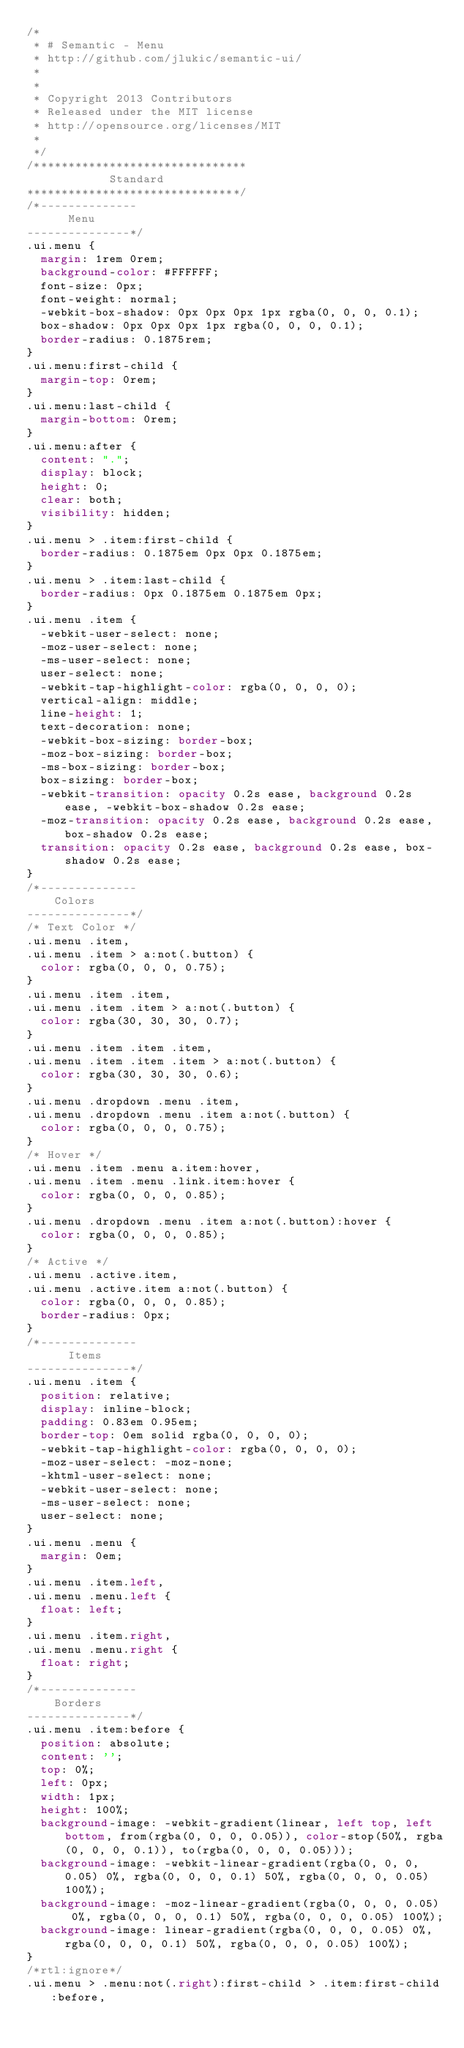<code> <loc_0><loc_0><loc_500><loc_500><_CSS_>/*
 * # Semantic - Menu
 * http://github.com/jlukic/semantic-ui/
 *
 *
 * Copyright 2013 Contributors
 * Released under the MIT license
 * http://opensource.org/licenses/MIT
 *
 */
/*******************************
            Standard
*******************************/
/*--------------
      Menu
---------------*/
.ui.menu {
  margin: 1rem 0rem;
  background-color: #FFFFFF;
  font-size: 0px;
  font-weight: normal;
  -webkit-box-shadow: 0px 0px 0px 1px rgba(0, 0, 0, 0.1);
  box-shadow: 0px 0px 0px 1px rgba(0, 0, 0, 0.1);
  border-radius: 0.1875rem;
}
.ui.menu:first-child {
  margin-top: 0rem;
}
.ui.menu:last-child {
  margin-bottom: 0rem;
}
.ui.menu:after {
  content: ".";
  display: block;
  height: 0;
  clear: both;
  visibility: hidden;
}
.ui.menu > .item:first-child {
  border-radius: 0.1875em 0px 0px 0.1875em;
}
.ui.menu > .item:last-child {
  border-radius: 0px 0.1875em 0.1875em 0px;
}
.ui.menu .item {
  -webkit-user-select: none;
  -moz-user-select: none;
  -ms-user-select: none;
  user-select: none;
  -webkit-tap-highlight-color: rgba(0, 0, 0, 0);
  vertical-align: middle;
  line-height: 1;
  text-decoration: none;
  -webkit-box-sizing: border-box;
  -moz-box-sizing: border-box;
  -ms-box-sizing: border-box;
  box-sizing: border-box;
  -webkit-transition: opacity 0.2s ease, background 0.2s ease, -webkit-box-shadow 0.2s ease;
  -moz-transition: opacity 0.2s ease, background 0.2s ease, box-shadow 0.2s ease;
  transition: opacity 0.2s ease, background 0.2s ease, box-shadow 0.2s ease;
}
/*--------------
    Colors
---------------*/
/* Text Color */
.ui.menu .item,
.ui.menu .item > a:not(.button) {
  color: rgba(0, 0, 0, 0.75);
}
.ui.menu .item .item,
.ui.menu .item .item > a:not(.button) {
  color: rgba(30, 30, 30, 0.7);
}
.ui.menu .item .item .item,
.ui.menu .item .item .item > a:not(.button) {
  color: rgba(30, 30, 30, 0.6);
}
.ui.menu .dropdown .menu .item,
.ui.menu .dropdown .menu .item a:not(.button) {
  color: rgba(0, 0, 0, 0.75);
}
/* Hover */
.ui.menu .item .menu a.item:hover,
.ui.menu .item .menu .link.item:hover {
  color: rgba(0, 0, 0, 0.85);
}
.ui.menu .dropdown .menu .item a:not(.button):hover {
  color: rgba(0, 0, 0, 0.85);
}
/* Active */
.ui.menu .active.item,
.ui.menu .active.item a:not(.button) {
  color: rgba(0, 0, 0, 0.85);
  border-radius: 0px;
}
/*--------------
      Items
---------------*/
.ui.menu .item {
  position: relative;
  display: inline-block;
  padding: 0.83em 0.95em;
  border-top: 0em solid rgba(0, 0, 0, 0);
  -webkit-tap-highlight-color: rgba(0, 0, 0, 0);
  -moz-user-select: -moz-none;
  -khtml-user-select: none;
  -webkit-user-select: none;
  -ms-user-select: none;
  user-select: none;
}
.ui.menu .menu {
  margin: 0em;
}
.ui.menu .item.left,
.ui.menu .menu.left {
  float: left;
}
.ui.menu .item.right,
.ui.menu .menu.right {
  float: right;
}
/*--------------
    Borders
---------------*/
.ui.menu .item:before {
  position: absolute;
  content: '';
  top: 0%;
  left: 0px;
  width: 1px;
  height: 100%;
  background-image: -webkit-gradient(linear, left top, left bottom, from(rgba(0, 0, 0, 0.05)), color-stop(50%, rgba(0, 0, 0, 0.1)), to(rgba(0, 0, 0, 0.05)));
  background-image: -webkit-linear-gradient(rgba(0, 0, 0, 0.05) 0%, rgba(0, 0, 0, 0.1) 50%, rgba(0, 0, 0, 0.05) 100%);
  background-image: -moz-linear-gradient(rgba(0, 0, 0, 0.05) 0%, rgba(0, 0, 0, 0.1) 50%, rgba(0, 0, 0, 0.05) 100%);
  background-image: linear-gradient(rgba(0, 0, 0, 0.05) 0%, rgba(0, 0, 0, 0.1) 50%, rgba(0, 0, 0, 0.05) 100%);
}
/*rtl:ignore*/
.ui.menu > .menu:not(.right):first-child > .item:first-child:before,</code> 